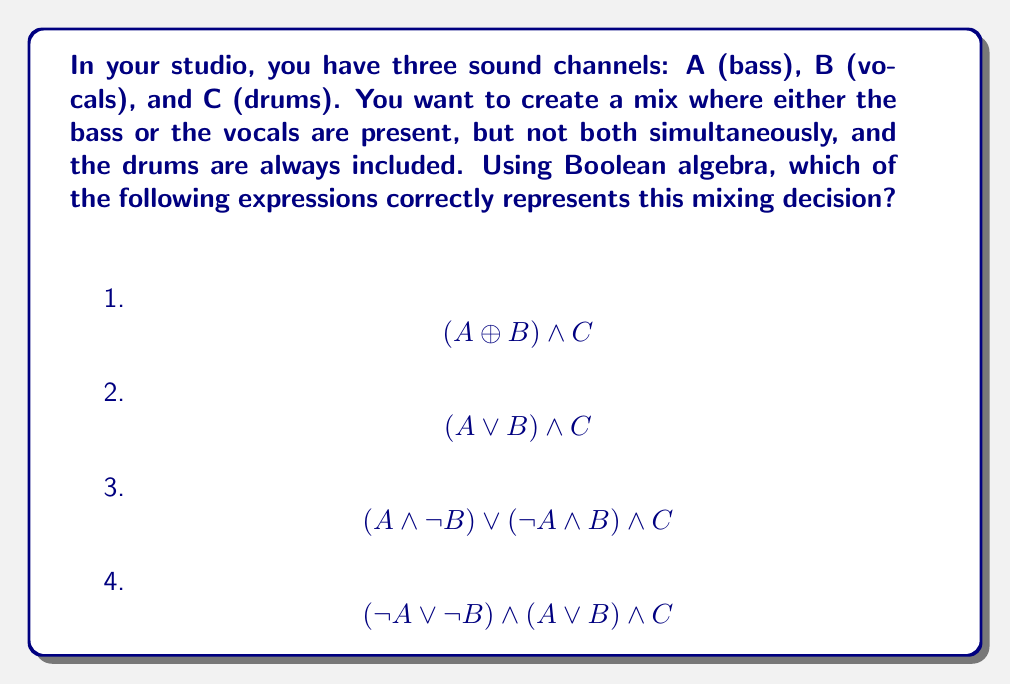Provide a solution to this math problem. Let's break this down step-by-step:

1) First, we need to understand what each Boolean operation means:
   $\land$ : AND
   $\lor$ : OR
   $\lnot$ : NOT
   $\oplus$ : XOR (exclusive OR)

2) The mixing decision requires:
   - Either bass (A) or vocals (B), but not both
   - Drums (C) always included

3) The expression for "either A or B, but not both" is known as XOR. It can be written in two ways:
   $A \oplus B$ or $(A \land \lnot B) \lor (\lnot A \land B)$

4) Since the drums (C) must always be included, we need to AND this with our XOR expression.

5) Let's evaluate each option:

   1) $$(A \oplus B) \land C$$ 
      This correctly represents our mixing decision.

   2) $$(A \lor B) \land C$$ 
      This allows for both A and B to be true simultaneously, which doesn't meet our requirement.

   3) $$(A \land \lnot B) \lor (\lnot A \land B) \land C$$ 
      This is incorrect because the C is only ANDed with the second part of the XOR expression.

   4) $$(\lnot A \lor \lnot B) \land (A \lor B) \land C$$ 
      This is a correct representation of XOR ANDed with C.

Therefore, both options 1 and 4 are correct representations of the desired mixing decision.
Answer: Options 1 and 4 are correct: $$(A \oplus B) \land C$$ and $$(\lnot A \lor \lnot B) \land (A \lor B) \land C$$ 